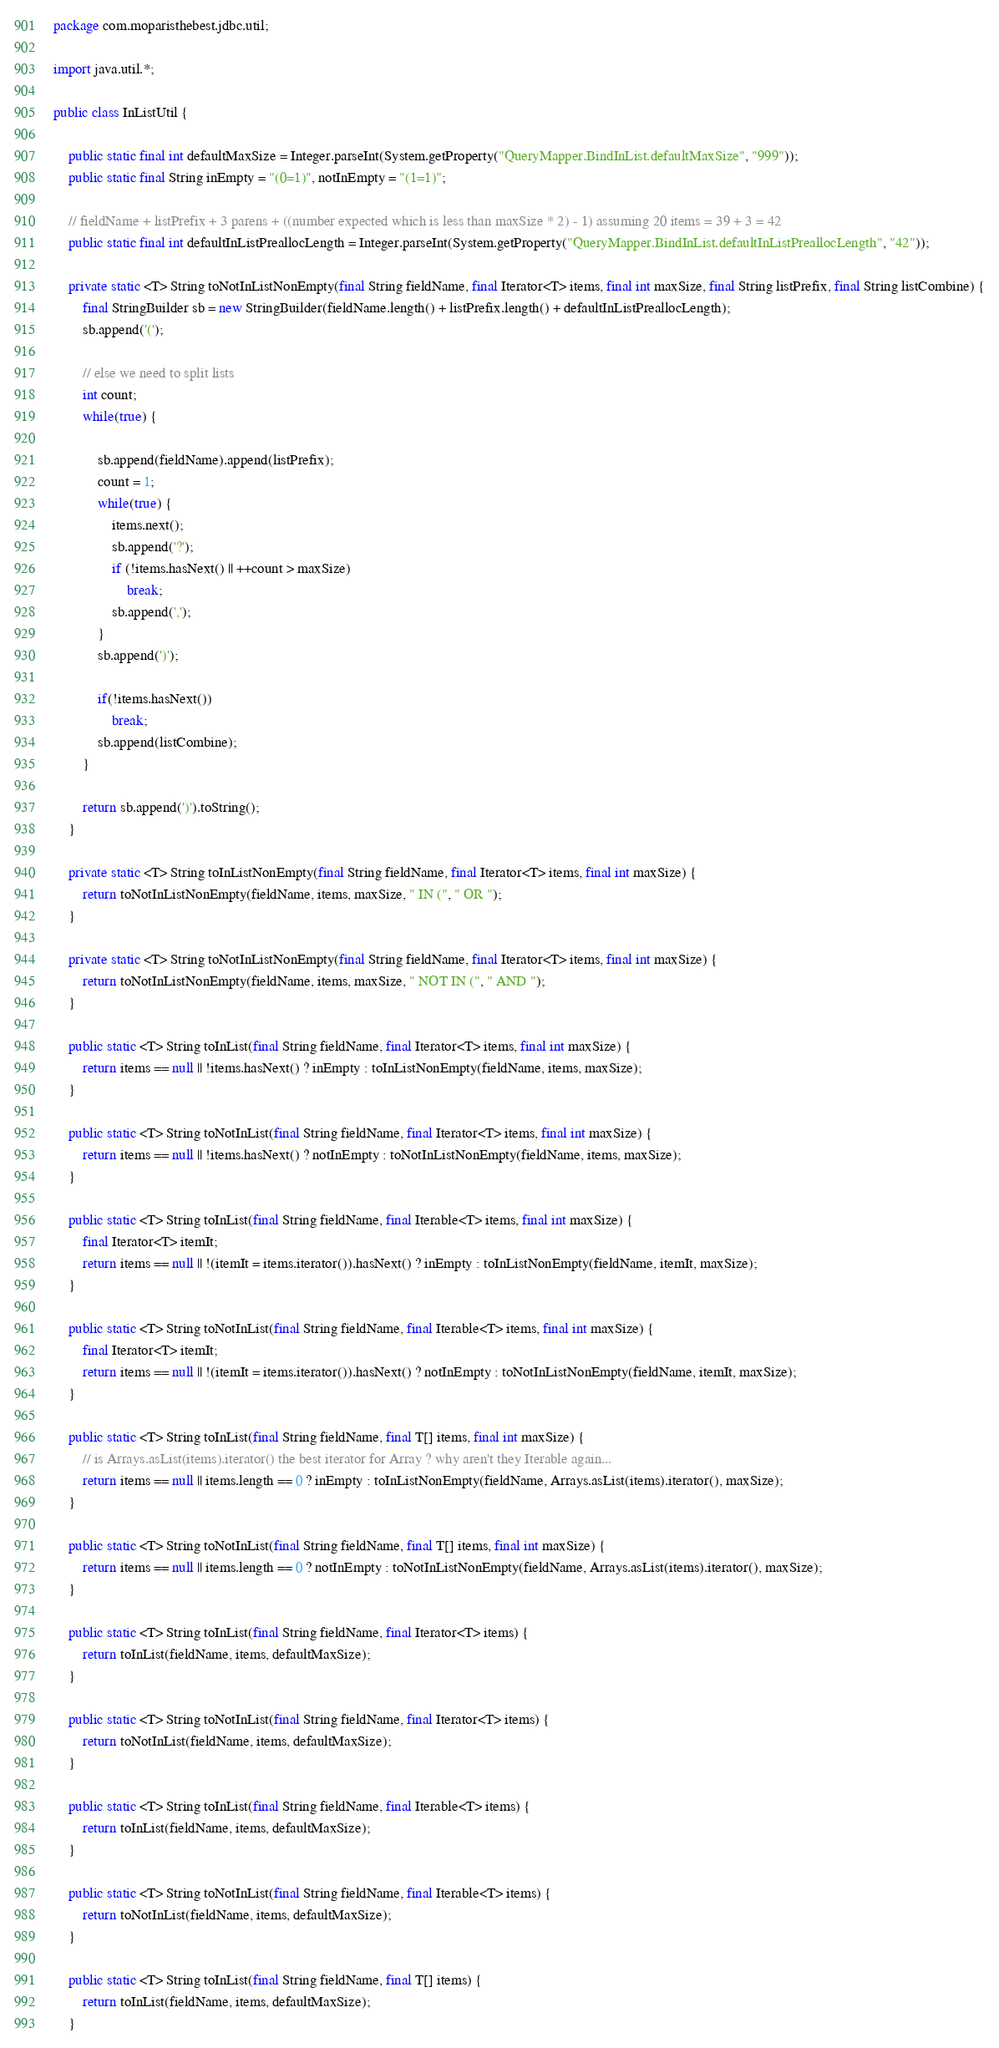Convert code to text. <code><loc_0><loc_0><loc_500><loc_500><_Java_>package com.moparisthebest.jdbc.util;

import java.util.*;

public class InListUtil {

    public static final int defaultMaxSize = Integer.parseInt(System.getProperty("QueryMapper.BindInList.defaultMaxSize", "999"));
    public static final String inEmpty = "(0=1)", notInEmpty = "(1=1)";

    // fieldName + listPrefix + 3 parens + ((number expected which is less than maxSize * 2) - 1) assuming 20 items = 39 + 3 = 42
    public static final int defaultInListPreallocLength = Integer.parseInt(System.getProperty("QueryMapper.BindInList.defaultInListPreallocLength", "42"));

    private static <T> String toNotInListNonEmpty(final String fieldName, final Iterator<T> items, final int maxSize, final String listPrefix, final String listCombine) {
        final StringBuilder sb = new StringBuilder(fieldName.length() + listPrefix.length() + defaultInListPreallocLength);
        sb.append('(');

        // else we need to split lists
        int count;
        while(true) {

            sb.append(fieldName).append(listPrefix);
            count = 1;
            while(true) {
                items.next();
                sb.append('?');
                if (!items.hasNext() || ++count > maxSize)
                    break;
                sb.append(',');
            }
            sb.append(')');

            if(!items.hasNext())
                break;
            sb.append(listCombine);
        }

        return sb.append(')').toString();
    }

    private static <T> String toInListNonEmpty(final String fieldName, final Iterator<T> items, final int maxSize) {
        return toNotInListNonEmpty(fieldName, items, maxSize, " IN (", " OR ");
    }

    private static <T> String toNotInListNonEmpty(final String fieldName, final Iterator<T> items, final int maxSize) {
        return toNotInListNonEmpty(fieldName, items, maxSize, " NOT IN (", " AND ");
    }

    public static <T> String toInList(final String fieldName, final Iterator<T> items, final int maxSize) {
        return items == null || !items.hasNext() ? inEmpty : toInListNonEmpty(fieldName, items, maxSize);
    }

    public static <T> String toNotInList(final String fieldName, final Iterator<T> items, final int maxSize) {
        return items == null || !items.hasNext() ? notInEmpty : toNotInListNonEmpty(fieldName, items, maxSize);
    }

    public static <T> String toInList(final String fieldName, final Iterable<T> items, final int maxSize) {
        final Iterator<T> itemIt;
        return items == null || !(itemIt = items.iterator()).hasNext() ? inEmpty : toInListNonEmpty(fieldName, itemIt, maxSize);
    }

    public static <T> String toNotInList(final String fieldName, final Iterable<T> items, final int maxSize) {
        final Iterator<T> itemIt;
        return items == null || !(itemIt = items.iterator()).hasNext() ? notInEmpty : toNotInListNonEmpty(fieldName, itemIt, maxSize);
    }

    public static <T> String toInList(final String fieldName, final T[] items, final int maxSize) {
        // is Arrays.asList(items).iterator() the best iterator for Array ? why aren't they Iterable again...
        return items == null || items.length == 0 ? inEmpty : toInListNonEmpty(fieldName, Arrays.asList(items).iterator(), maxSize);
    }

    public static <T> String toNotInList(final String fieldName, final T[] items, final int maxSize) {
        return items == null || items.length == 0 ? notInEmpty : toNotInListNonEmpty(fieldName, Arrays.asList(items).iterator(), maxSize);
    }

    public static <T> String toInList(final String fieldName, final Iterator<T> items) {
        return toInList(fieldName, items, defaultMaxSize);
    }

    public static <T> String toNotInList(final String fieldName, final Iterator<T> items) {
        return toNotInList(fieldName, items, defaultMaxSize);
    }

    public static <T> String toInList(final String fieldName, final Iterable<T> items) {
        return toInList(fieldName, items, defaultMaxSize);
    }

    public static <T> String toNotInList(final String fieldName, final Iterable<T> items) {
        return toNotInList(fieldName, items, defaultMaxSize);
    }

    public static <T> String toInList(final String fieldName, final T[] items) {
        return toInList(fieldName, items, defaultMaxSize);
    }
</code> 